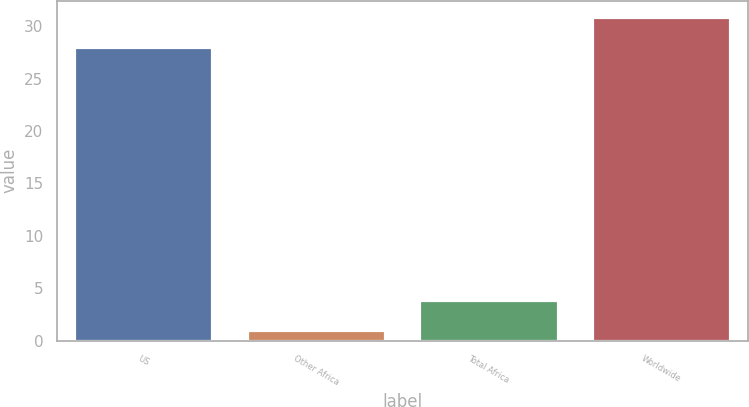<chart> <loc_0><loc_0><loc_500><loc_500><bar_chart><fcel>US<fcel>Other Africa<fcel>Total Africa<fcel>Worldwide<nl><fcel>28<fcel>1<fcel>3.9<fcel>30.9<nl></chart> 